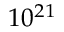Convert formula to latex. <formula><loc_0><loc_0><loc_500><loc_500>1 0 ^ { 2 1 }</formula> 